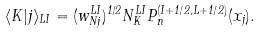<formula> <loc_0><loc_0><loc_500><loc_500>\langle K | j \rangle _ { L I } = ( w _ { N j } ^ { L I } ) ^ { 1 / 2 } N ^ { L I } _ { K } P ^ { ( I + 1 / 2 , L + 1 / 2 ) } _ { n } ( x _ { j } ) .</formula> 